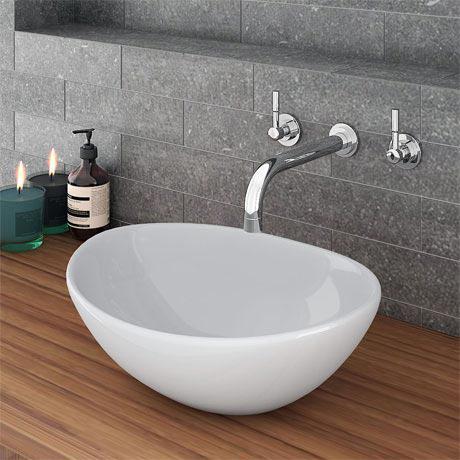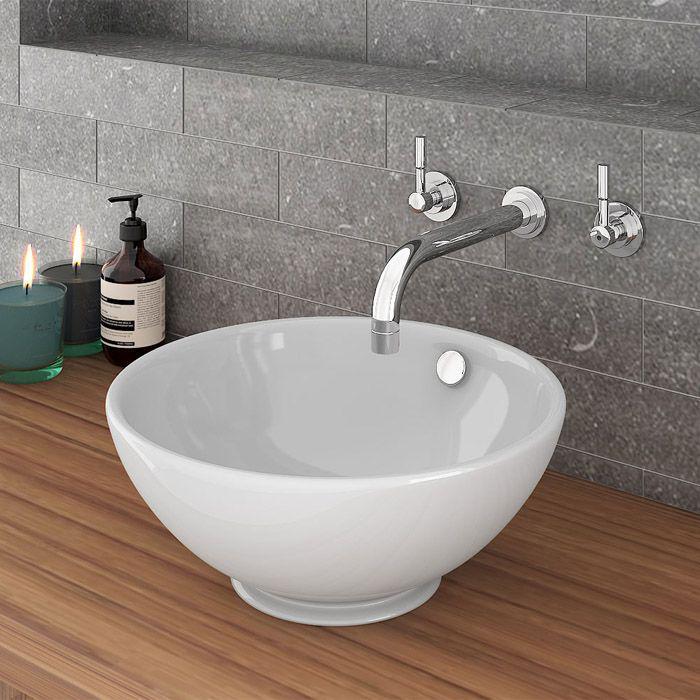The first image is the image on the left, the second image is the image on the right. Evaluate the accuracy of this statement regarding the images: "At least one of the sinks depicted has lever handles flanking the faucet.". Is it true? Answer yes or no. Yes. 